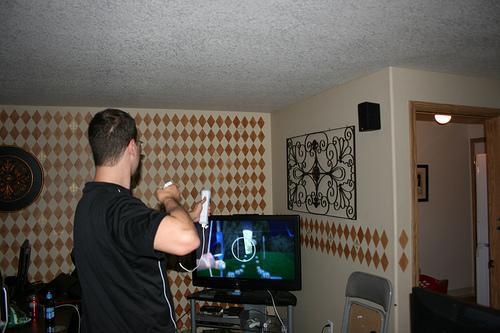How many people are shown?
Give a very brief answer. 1. How many arms is this man holding straight out?
Give a very brief answer. 1. 